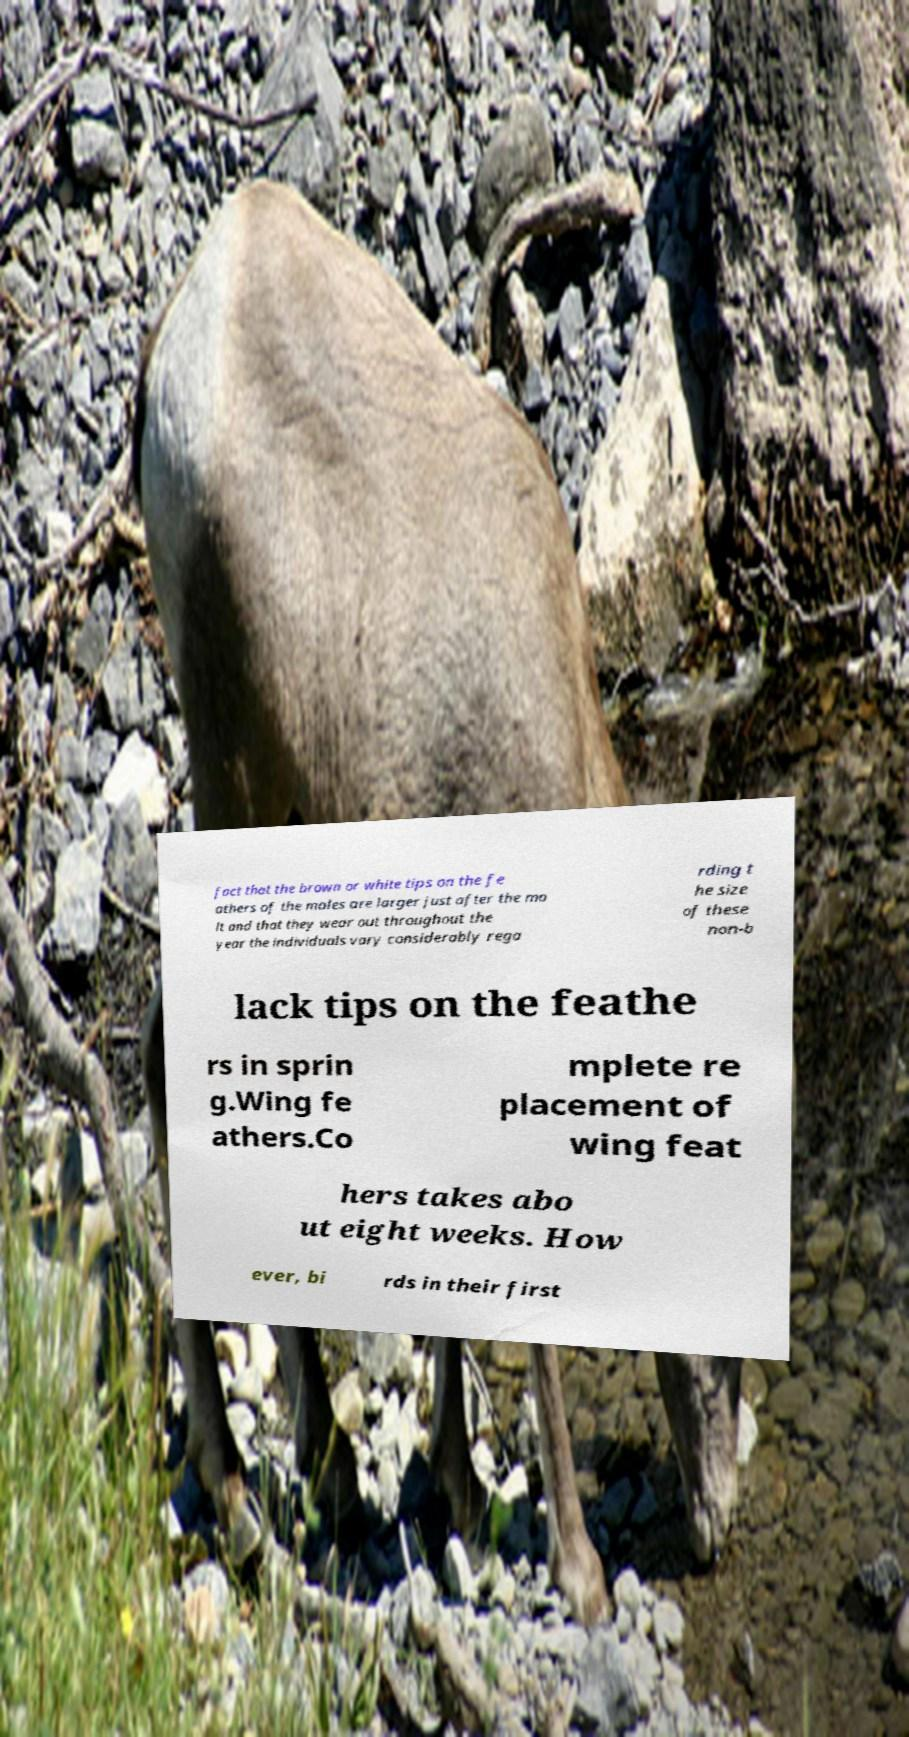Can you accurately transcribe the text from the provided image for me? fact that the brown or white tips on the fe athers of the males are larger just after the mo lt and that they wear out throughout the year the individuals vary considerably rega rding t he size of these non-b lack tips on the feathe rs in sprin g.Wing fe athers.Co mplete re placement of wing feat hers takes abo ut eight weeks. How ever, bi rds in their first 